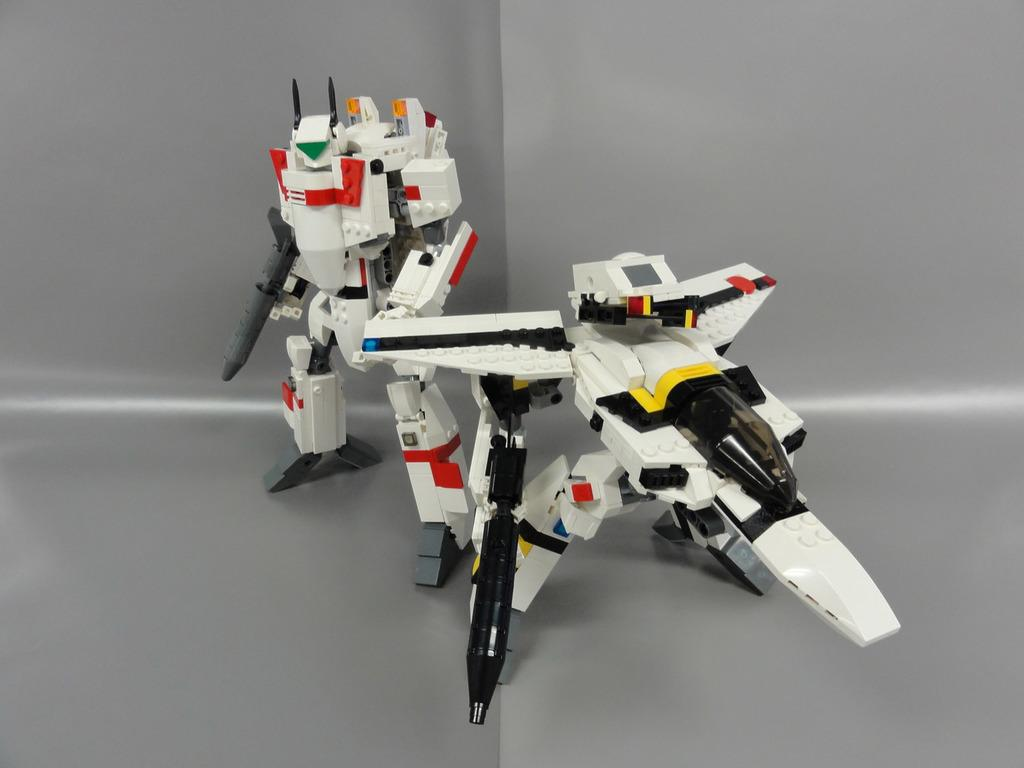What objects are present in the image? There are toys in the image. Can you describe the appearance of the toys? The toys have multiple colors. What is the color of the background in the image? The background of the image is grey. What type of bell can be seen hanging from the houses in the image? There are no houses or bells present in the image; it only features toys with multiple colors against a grey background. 